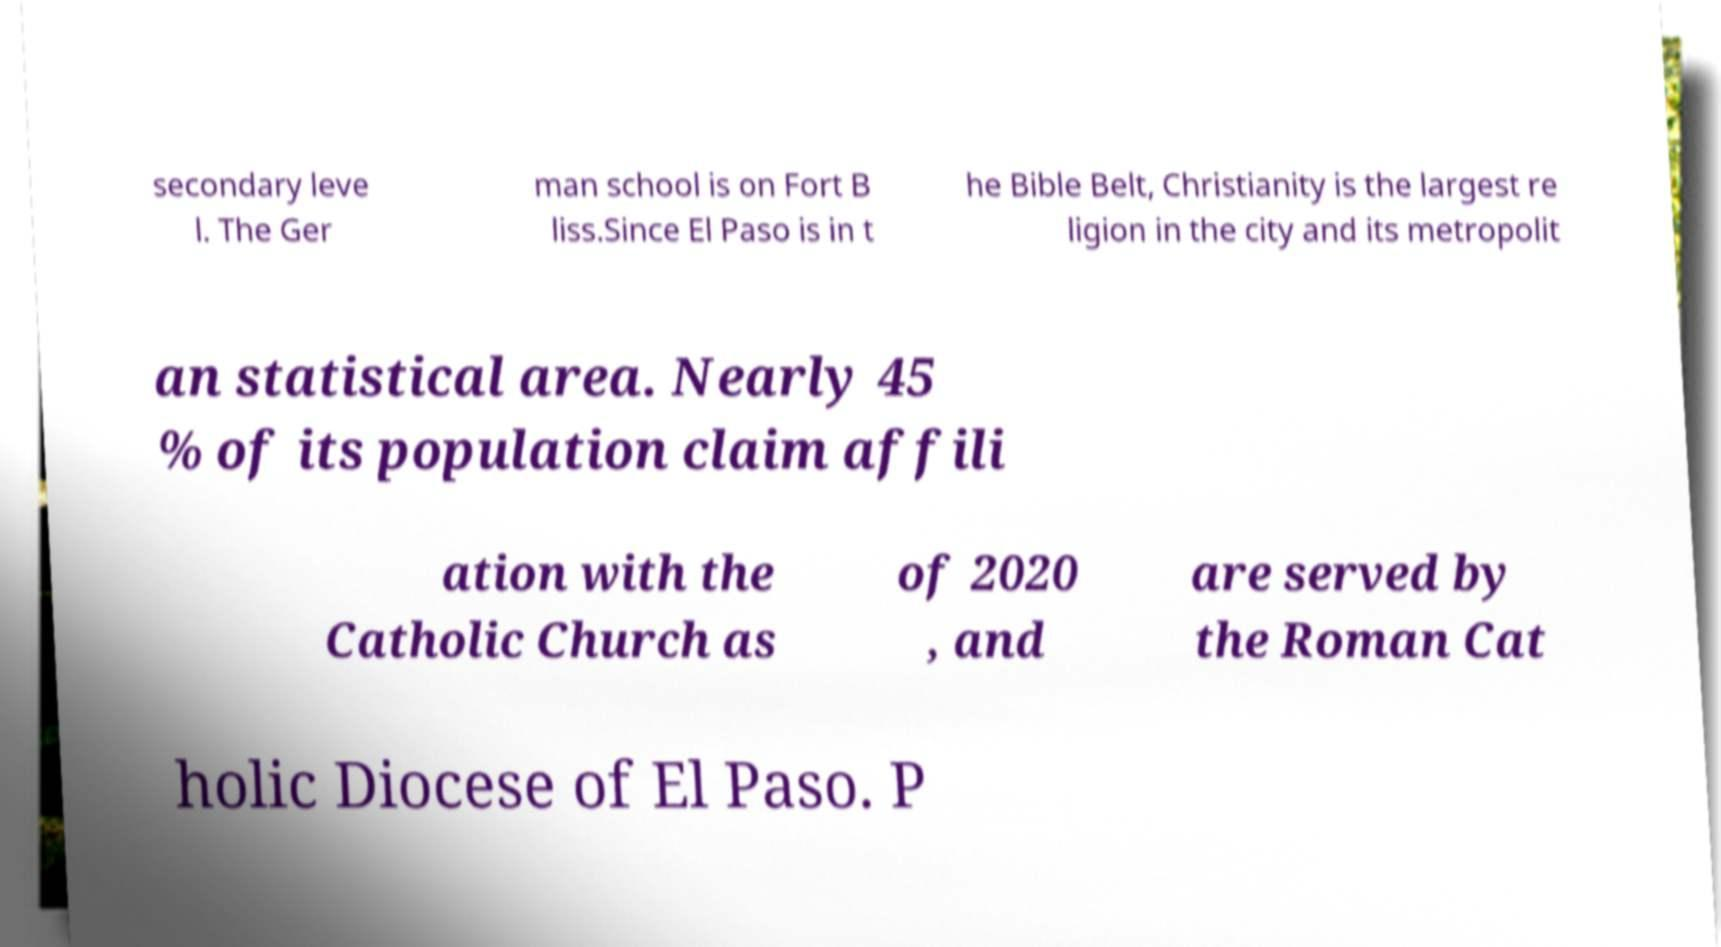Can you read and provide the text displayed in the image?This photo seems to have some interesting text. Can you extract and type it out for me? secondary leve l. The Ger man school is on Fort B liss.Since El Paso is in t he Bible Belt, Christianity is the largest re ligion in the city and its metropolit an statistical area. Nearly 45 % of its population claim affili ation with the Catholic Church as of 2020 , and are served by the Roman Cat holic Diocese of El Paso. P 